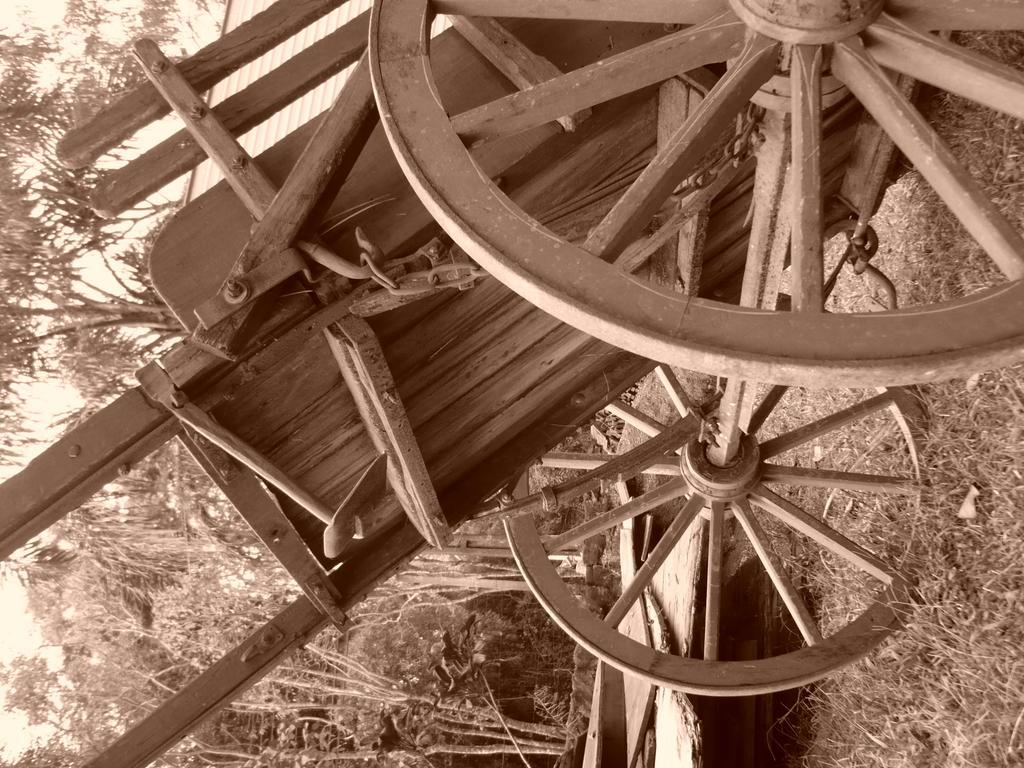Please provide a concise description of this image. In this picture I can see there is a bull cart it is made of wood and there is grass on the floor and there are trees. The sky is clear. 